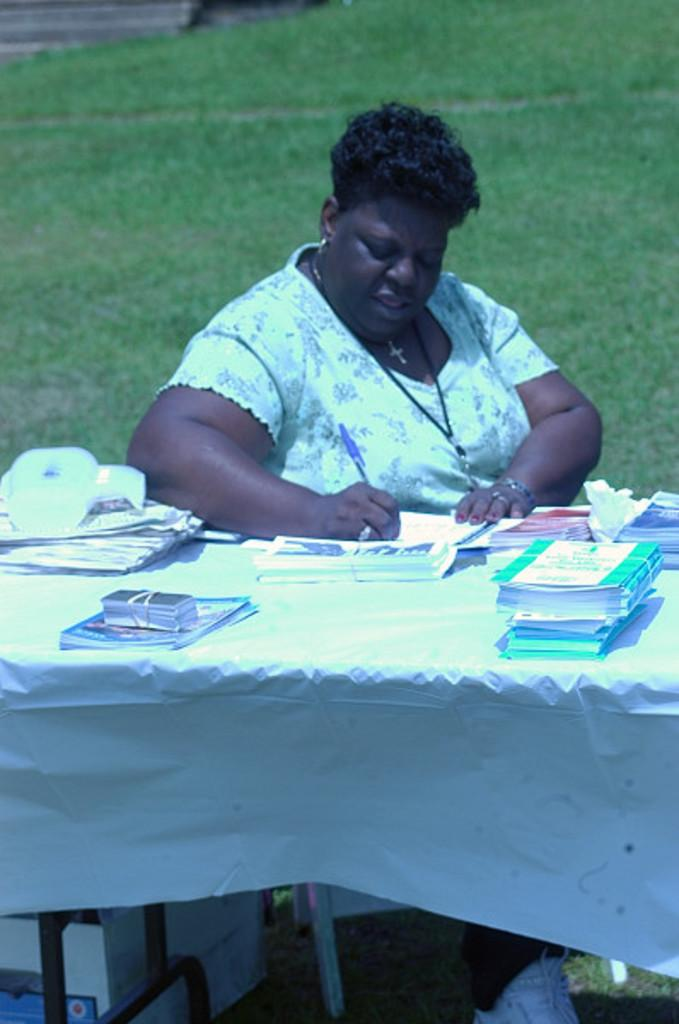What is covering the table in the image? There is a sheet on the table. What else can be seen on the table? There are books and cards on the table. Can you describe what is under the table? There are things under the table, but their specific nature is not clear from the image. What is the woman beside the table doing? The woman is holding a pen beside the table. What can be seen in the background of the image? There is grass visible in the background. What type of development is taking place in the image? There is no indication of any development taking place in the image; it primarily features a table with various items on it and a woman holding a pen. Can you hear the woman laughing in the image? There is no sound in the image, so it is not possible to determine if the woman is laughing or not. 